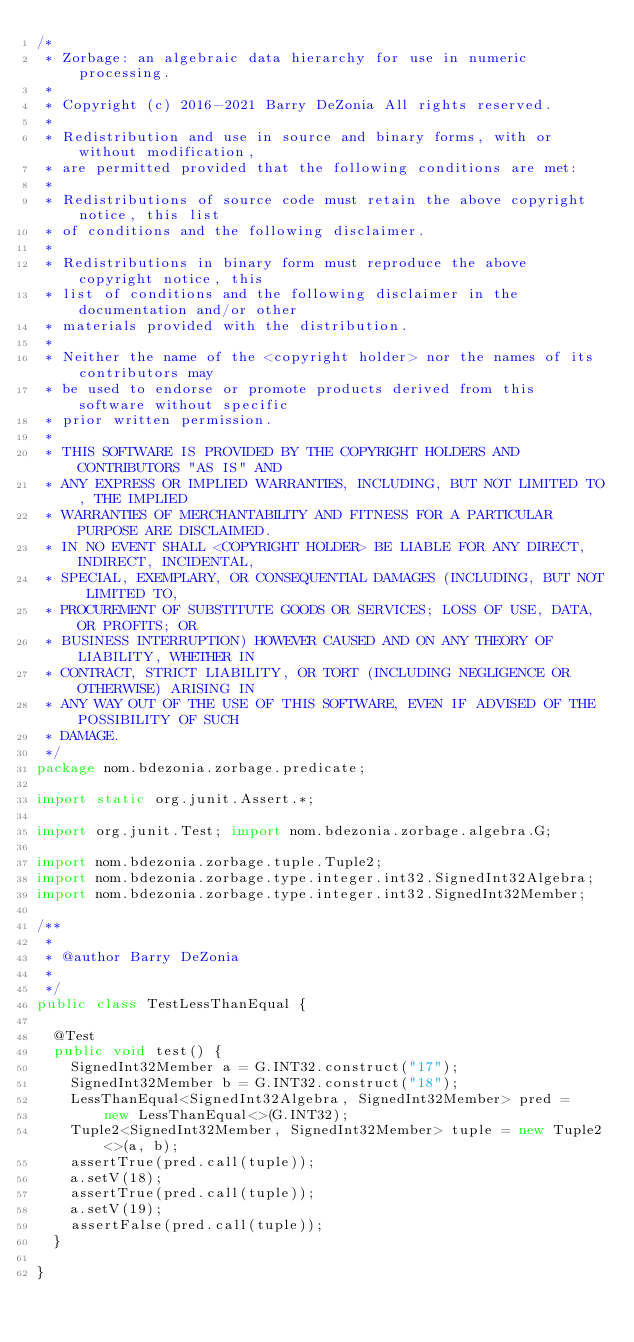Convert code to text. <code><loc_0><loc_0><loc_500><loc_500><_Java_>/*
 * Zorbage: an algebraic data hierarchy for use in numeric processing.
 *
 * Copyright (c) 2016-2021 Barry DeZonia All rights reserved.
 * 
 * Redistribution and use in source and binary forms, with or without modification,
 * are permitted provided that the following conditions are met:
 * 
 * Redistributions of source code must retain the above copyright notice, this list
 * of conditions and the following disclaimer.
 * 
 * Redistributions in binary form must reproduce the above copyright notice, this
 * list of conditions and the following disclaimer in the documentation and/or other
 * materials provided with the distribution.
 * 
 * Neither the name of the <copyright holder> nor the names of its contributors may
 * be used to endorse or promote products derived from this software without specific
 * prior written permission.
 * 
 * THIS SOFTWARE IS PROVIDED BY THE COPYRIGHT HOLDERS AND CONTRIBUTORS "AS IS" AND
 * ANY EXPRESS OR IMPLIED WARRANTIES, INCLUDING, BUT NOT LIMITED TO, THE IMPLIED
 * WARRANTIES OF MERCHANTABILITY AND FITNESS FOR A PARTICULAR PURPOSE ARE DISCLAIMED.
 * IN NO EVENT SHALL <COPYRIGHT HOLDER> BE LIABLE FOR ANY DIRECT, INDIRECT, INCIDENTAL,
 * SPECIAL, EXEMPLARY, OR CONSEQUENTIAL DAMAGES (INCLUDING, BUT NOT LIMITED TO,
 * PROCUREMENT OF SUBSTITUTE GOODS OR SERVICES; LOSS OF USE, DATA, OR PROFITS; OR
 * BUSINESS INTERRUPTION) HOWEVER CAUSED AND ON ANY THEORY OF LIABILITY, WHETHER IN
 * CONTRACT, STRICT LIABILITY, OR TORT (INCLUDING NEGLIGENCE OR OTHERWISE) ARISING IN
 * ANY WAY OUT OF THE USE OF THIS SOFTWARE, EVEN IF ADVISED OF THE POSSIBILITY OF SUCH
 * DAMAGE.
 */
package nom.bdezonia.zorbage.predicate;

import static org.junit.Assert.*;

import org.junit.Test; import nom.bdezonia.zorbage.algebra.G;

import nom.bdezonia.zorbage.tuple.Tuple2;
import nom.bdezonia.zorbage.type.integer.int32.SignedInt32Algebra;
import nom.bdezonia.zorbage.type.integer.int32.SignedInt32Member;

/**
 * 
 * @author Barry DeZonia
 *
 */
public class TestLessThanEqual {

	@Test
	public void test() {
		SignedInt32Member a = G.INT32.construct("17");
		SignedInt32Member b = G.INT32.construct("18");
		LessThanEqual<SignedInt32Algebra, SignedInt32Member> pred = 
				new LessThanEqual<>(G.INT32);
		Tuple2<SignedInt32Member, SignedInt32Member> tuple = new Tuple2<>(a, b);
		assertTrue(pred.call(tuple));
		a.setV(18);
		assertTrue(pred.call(tuple));
		a.setV(19);
		assertFalse(pred.call(tuple));
	}

}
</code> 